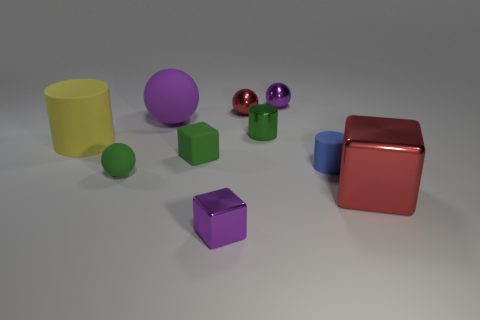Subtract all tiny purple shiny balls. How many balls are left? 3 Subtract all cyan cylinders. How many purple spheres are left? 2 Subtract 1 blocks. How many blocks are left? 2 Subtract all green cylinders. How many cylinders are left? 2 Subtract all cylinders. How many objects are left? 7 Subtract all brown blocks. Subtract all yellow cylinders. How many blocks are left? 3 Add 2 tiny green spheres. How many tiny green spheres exist? 3 Subtract 0 gray cubes. How many objects are left? 10 Subtract all tiny purple matte balls. Subtract all small green cylinders. How many objects are left? 9 Add 7 red metallic cubes. How many red metallic cubes are left? 8 